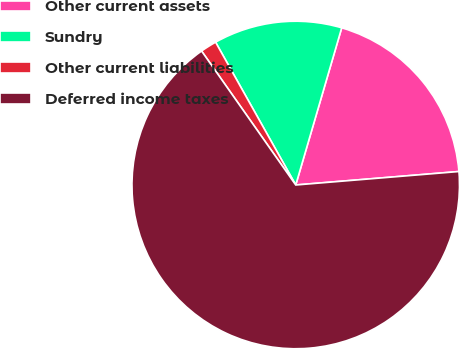Convert chart. <chart><loc_0><loc_0><loc_500><loc_500><pie_chart><fcel>Other current assets<fcel>Sundry<fcel>Other current liabilities<fcel>Deferred income taxes<nl><fcel>19.16%<fcel>12.67%<fcel>1.61%<fcel>66.56%<nl></chart> 